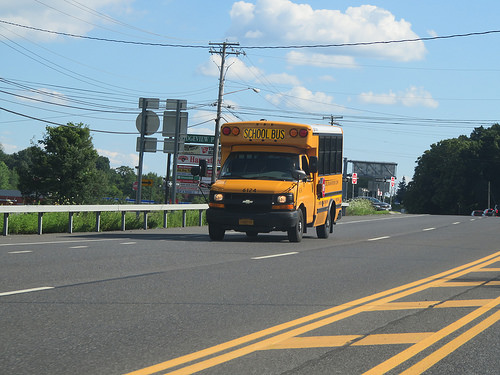<image>
Is the car to the left of the bus? No. The car is not to the left of the bus. From this viewpoint, they have a different horizontal relationship. 